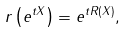<formula> <loc_0><loc_0><loc_500><loc_500>r \left ( e ^ { t X } \right ) = e ^ { t R ( X ) } ,</formula> 